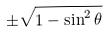Convert formula to latex. <formula><loc_0><loc_0><loc_500><loc_500>\pm \sqrt { 1 - \sin ^ { 2 } \theta }</formula> 